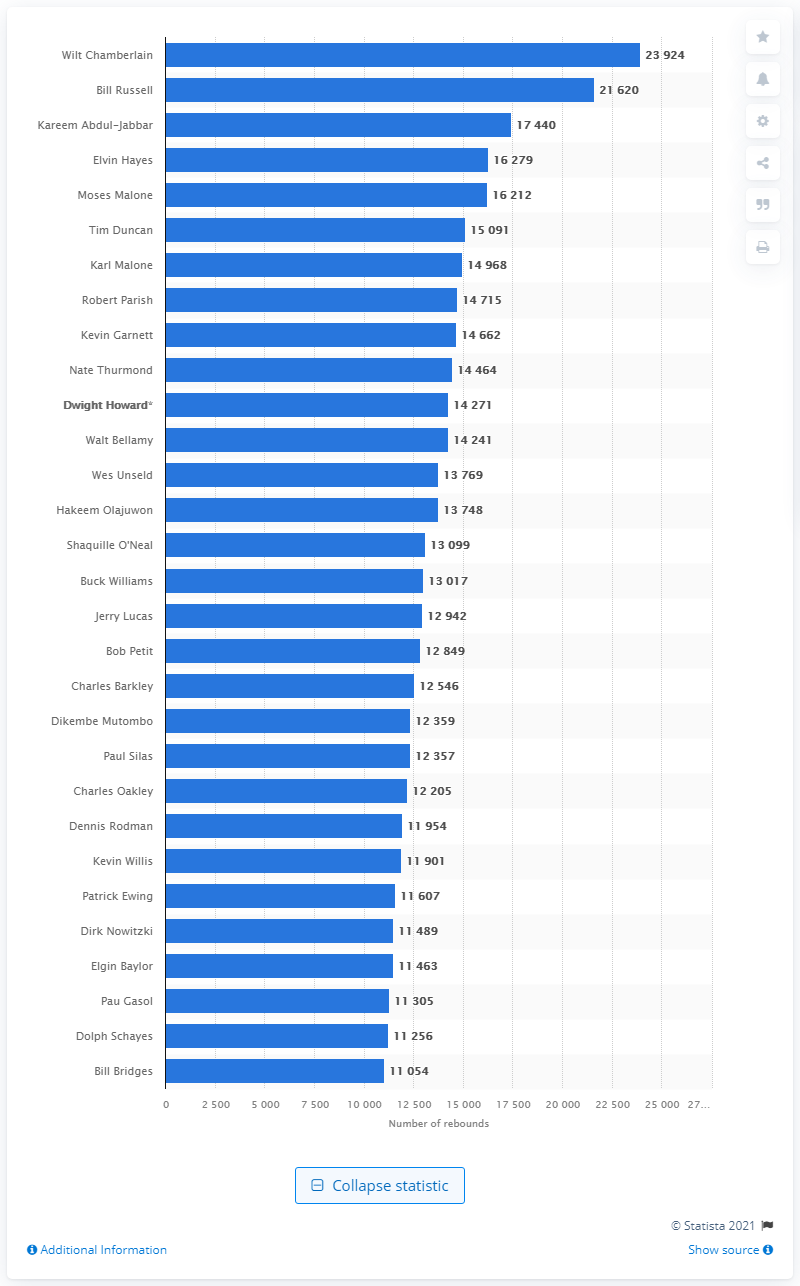Specify some key components in this picture. Wilt Chamberlain is the all-time rebound leader of the National Basketball Association. 